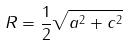Convert formula to latex. <formula><loc_0><loc_0><loc_500><loc_500>R = \frac { 1 } { 2 } \sqrt { a ^ { 2 } + c ^ { 2 } }</formula> 